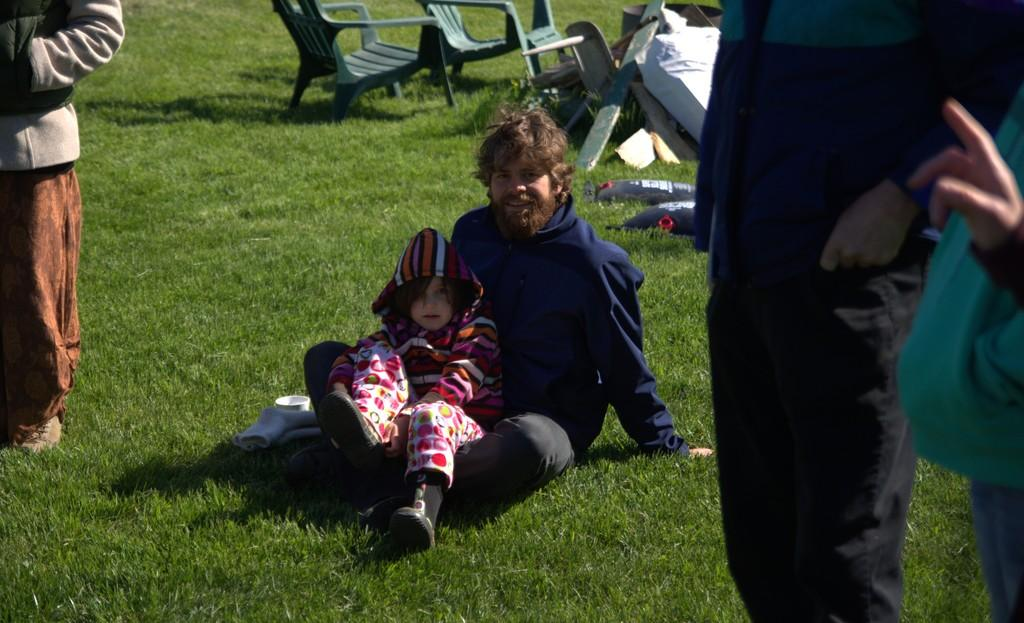Who or what is present in the image? There are people in the image. What are the people sitting on in the image? There are chairs in the image for the people to sit on. What type of natural environment is visible in the image? There is grass in the image, suggesting a natural setting. Can you describe any other objects or features in the image? There are unspecified objects in the image, but their nature is not clear from the provided facts. What type of smoke can be seen coming from the produce in the image? There is no smoke or produce present in the image; it features people and chairs in a grassy environment. 